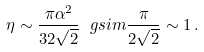Convert formula to latex. <formula><loc_0><loc_0><loc_500><loc_500>\eta \sim \frac { \pi \alpha ^ { 2 } } { 3 2 \sqrt { 2 } } \ g s i m \frac { \pi } { 2 \sqrt { 2 } } \sim 1 \, .</formula> 